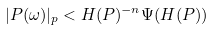<formula> <loc_0><loc_0><loc_500><loc_500>| P ( \omega ) | _ { p } < H ( P ) ^ { - n } \Psi ( H ( P ) )</formula> 